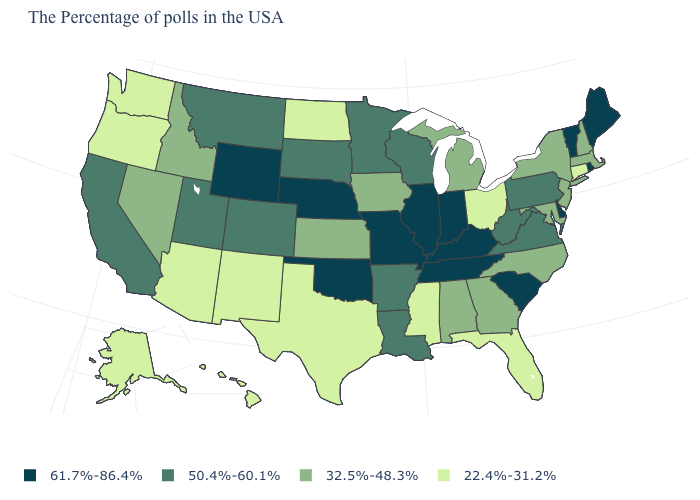Does Ohio have the lowest value in the USA?
Concise answer only. Yes. What is the value of North Carolina?
Keep it brief. 32.5%-48.3%. What is the value of South Carolina?
Give a very brief answer. 61.7%-86.4%. Does Missouri have the highest value in the MidWest?
Write a very short answer. Yes. Name the states that have a value in the range 61.7%-86.4%?
Quick response, please. Maine, Rhode Island, Vermont, Delaware, South Carolina, Kentucky, Indiana, Tennessee, Illinois, Missouri, Nebraska, Oklahoma, Wyoming. What is the value of North Carolina?
Keep it brief. 32.5%-48.3%. Does Alaska have a lower value than Florida?
Concise answer only. No. What is the lowest value in states that border Maryland?
Write a very short answer. 50.4%-60.1%. What is the lowest value in the USA?
Quick response, please. 22.4%-31.2%. What is the lowest value in the Northeast?
Short answer required. 22.4%-31.2%. What is the highest value in states that border Oklahoma?
Answer briefly. 61.7%-86.4%. What is the lowest value in the USA?
Give a very brief answer. 22.4%-31.2%. Among the states that border Delaware , does Maryland have the highest value?
Be succinct. No. Does Oregon have the lowest value in the USA?
Quick response, please. Yes. Among the states that border Rhode Island , which have the lowest value?
Give a very brief answer. Connecticut. 